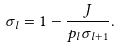<formula> <loc_0><loc_0><loc_500><loc_500>\sigma _ { l } = 1 - \frac { J } { p _ { l } \sigma _ { l + 1 } } .</formula> 